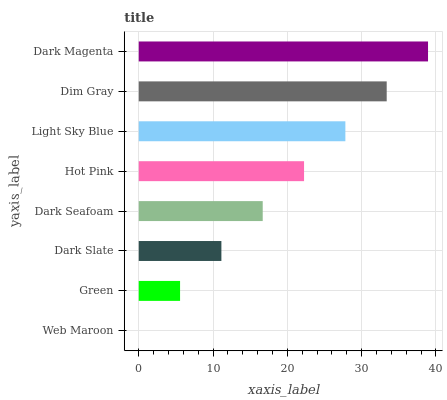Is Web Maroon the minimum?
Answer yes or no. Yes. Is Dark Magenta the maximum?
Answer yes or no. Yes. Is Green the minimum?
Answer yes or no. No. Is Green the maximum?
Answer yes or no. No. Is Green greater than Web Maroon?
Answer yes or no. Yes. Is Web Maroon less than Green?
Answer yes or no. Yes. Is Web Maroon greater than Green?
Answer yes or no. No. Is Green less than Web Maroon?
Answer yes or no. No. Is Hot Pink the high median?
Answer yes or no. Yes. Is Dark Seafoam the low median?
Answer yes or no. Yes. Is Dark Slate the high median?
Answer yes or no. No. Is Hot Pink the low median?
Answer yes or no. No. 